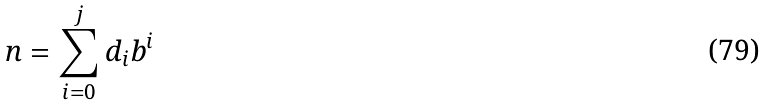Convert formula to latex. <formula><loc_0><loc_0><loc_500><loc_500>n = \sum _ { i = 0 } ^ { j } d _ { i } b ^ { i }</formula> 